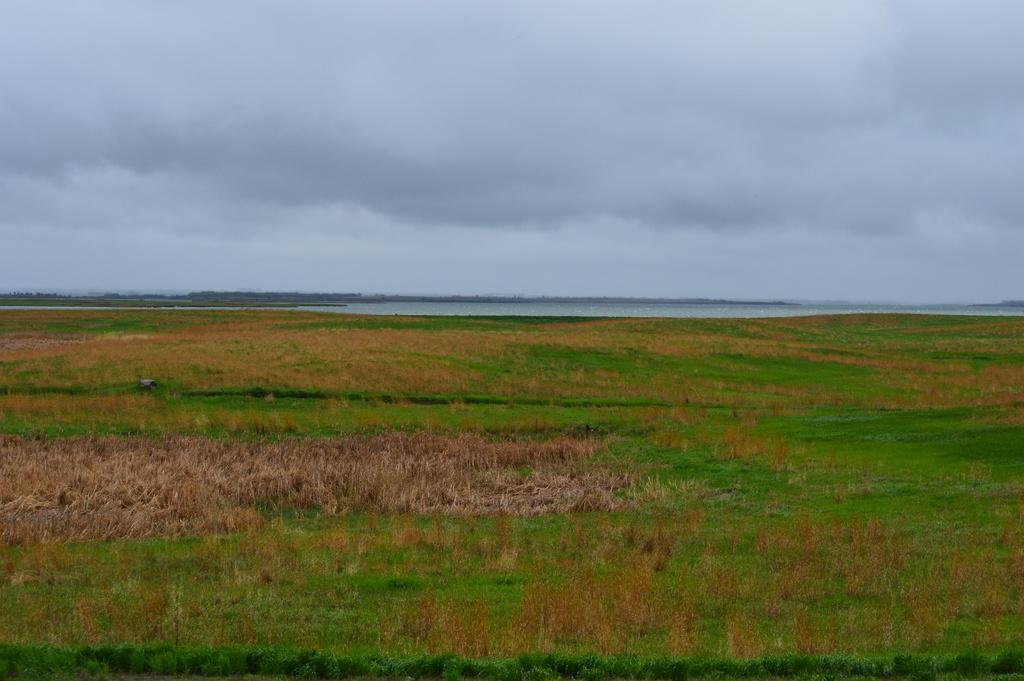What is visible in the image? The sky is visible in the image. Can you describe the condition of the sky? The sky is cloudy in the image. What type of drug can be seen in the image? There is no drug present in the image; it only features the sky. Are there any rail tracks visible in the image? There are no rail tracks present in the image. 